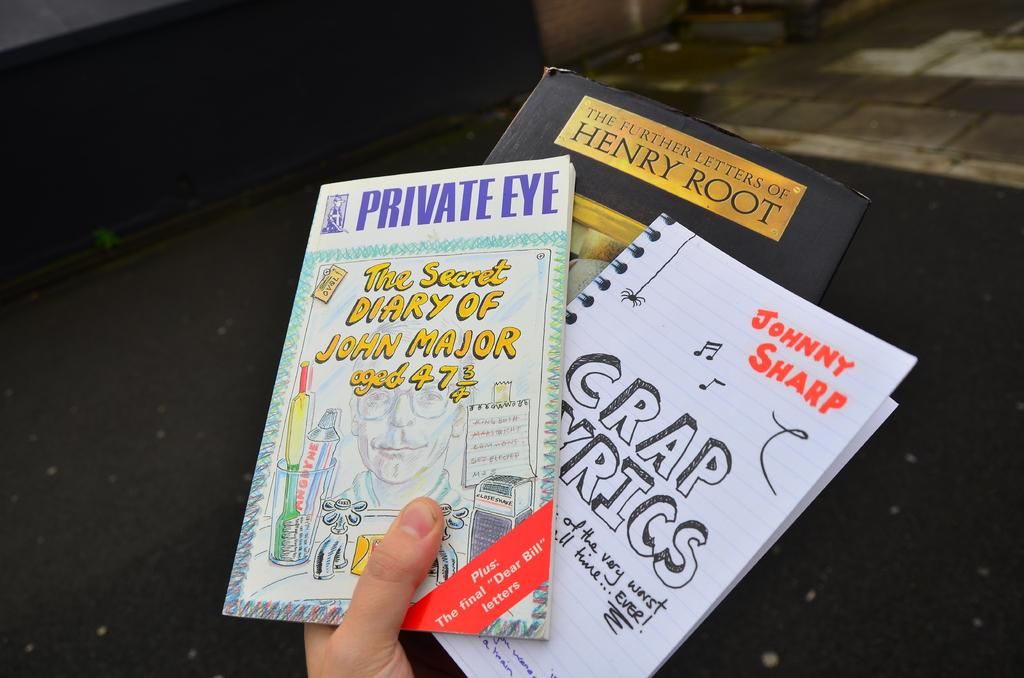Who wrote crap lyrics?
Ensure brevity in your answer.  Johnny sharp. 